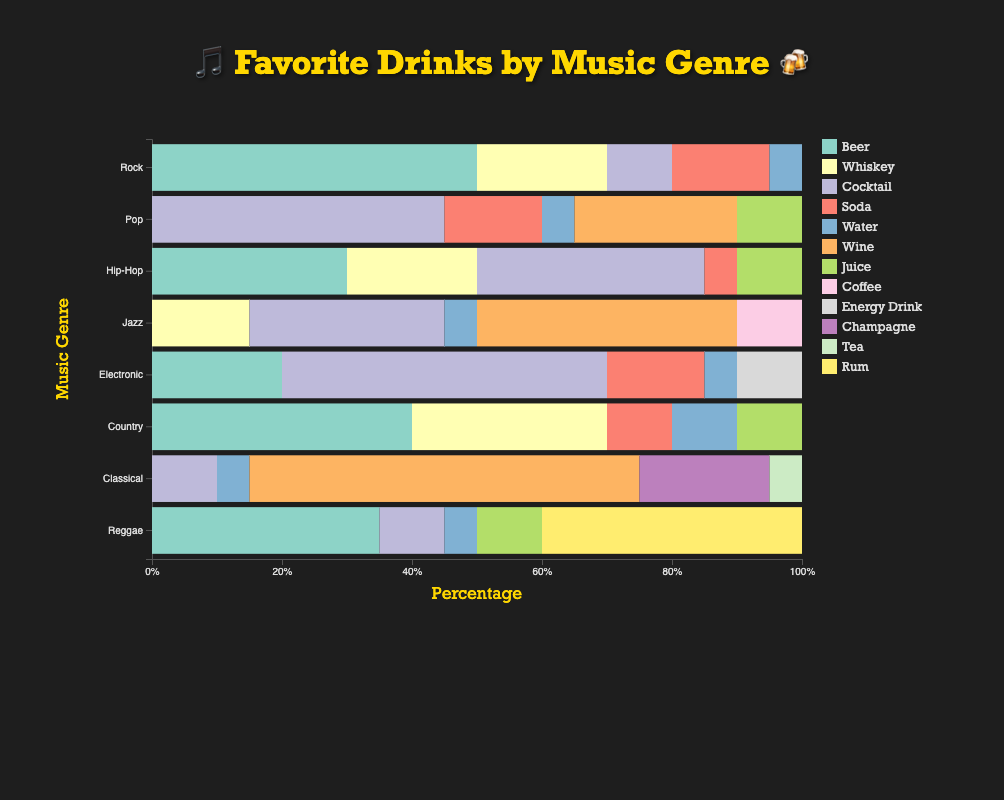Which genre has the highest percentage of Beer fans? By examining the stacked bar chart, look for the genre with the longest section colored in the shade representing Beer. Rock has the longest Beer segment.
Answer: Rock Which drink is most popular in Classical music fans? Look at the Classical genre bar and identify the largest colored segment. The largest segment is for Wine.
Answer: Wine How much more popular is Cocktail among Pop fans compared to Hip-Hop fans? Identify the Cocktail segments for both genres and calculate the difference. Pop has a 45% Cocktail preference, and Hip-Hop has 35%, so the difference is 45% - 35% = 10%.
Answer: 10% Which genre has the least preference for Cocktails? Examine the Cocktail segment for each genre and find the shortest one. Classical has the shortest Cocktail segment.
Answer: Classical Compare the total percentage of Whiskey fans in Rock and Country genres. Which genre has more, and by how much? Add up the Whiskey segments for both genres. Rock has 20%, and Country has 30% Whiskey fans. 30% - 20% = 10%, so Country has 10% more.
Answer: Country by 10% For which genre is Water the least popular drink? Look for the shortest segment representing Water across all genres. It's the least in Jazz, with only 5%.
Answer: Jazz If you add up the percentages of Soda and Juice for Hip-Hop fans, what would be the total? Add the Soda and Juice sections for Hip-Hop. Juice is 10% and Soda is 5%, so total is 10% + 5% = 15%.
Answer: 15% Which genre has an equal preference for Soda and Juice? Find a genre where the length of the segments for Soda and Juice are equal. In Country, both Soda and Juice have a 10% segment.
Answer: Country What is the combined percentage of Wine and Champagne fans in Classical? Add the percentages of Wine and Champagne in the Classical genre. Wine is 60% and Champagne is 20%, so 60% + 20% = 80%.
Answer: 80% 